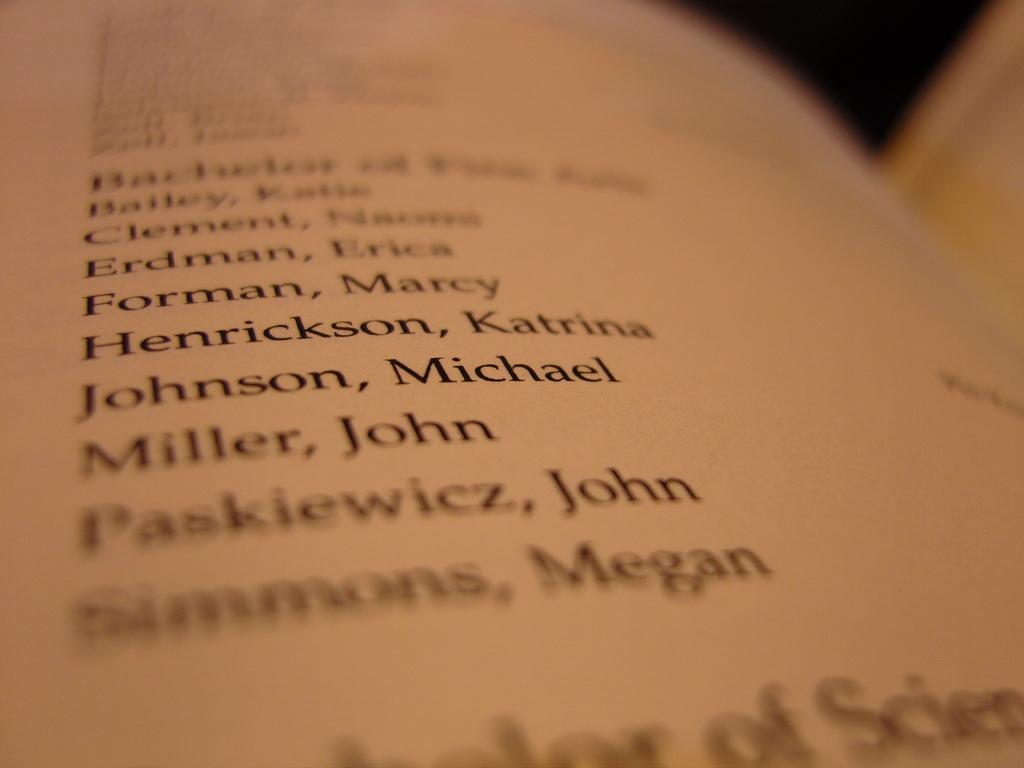What names are listed on that book page?
Keep it short and to the point. Forman marcy, henrickson katrina, johnson michael, miller john, paskiewicz john, simmons megan. Does henrickson come before or after miller?
Your answer should be compact. Before. 